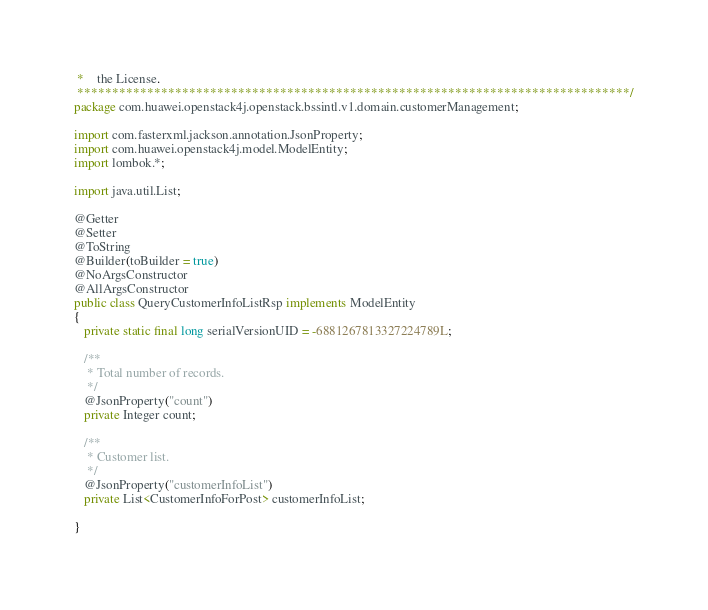<code> <loc_0><loc_0><loc_500><loc_500><_Java_> * 	the License.
 *******************************************************************************/
package com.huawei.openstack4j.openstack.bssintl.v1.domain.customerManagement;

import com.fasterxml.jackson.annotation.JsonProperty;
import com.huawei.openstack4j.model.ModelEntity;
import lombok.*;

import java.util.List;

@Getter
@Setter
@ToString
@Builder(toBuilder = true)
@NoArgsConstructor
@AllArgsConstructor
public class QueryCustomerInfoListRsp implements ModelEntity
{
   private static final long serialVersionUID = -6881267813327224789L;

   /**
    * Total number of records.
    */
   @JsonProperty("count")
   private Integer count;

   /**
    * Customer list.
    */
   @JsonProperty("customerInfoList")
   private List<CustomerInfoForPost> customerInfoList;

}


</code> 